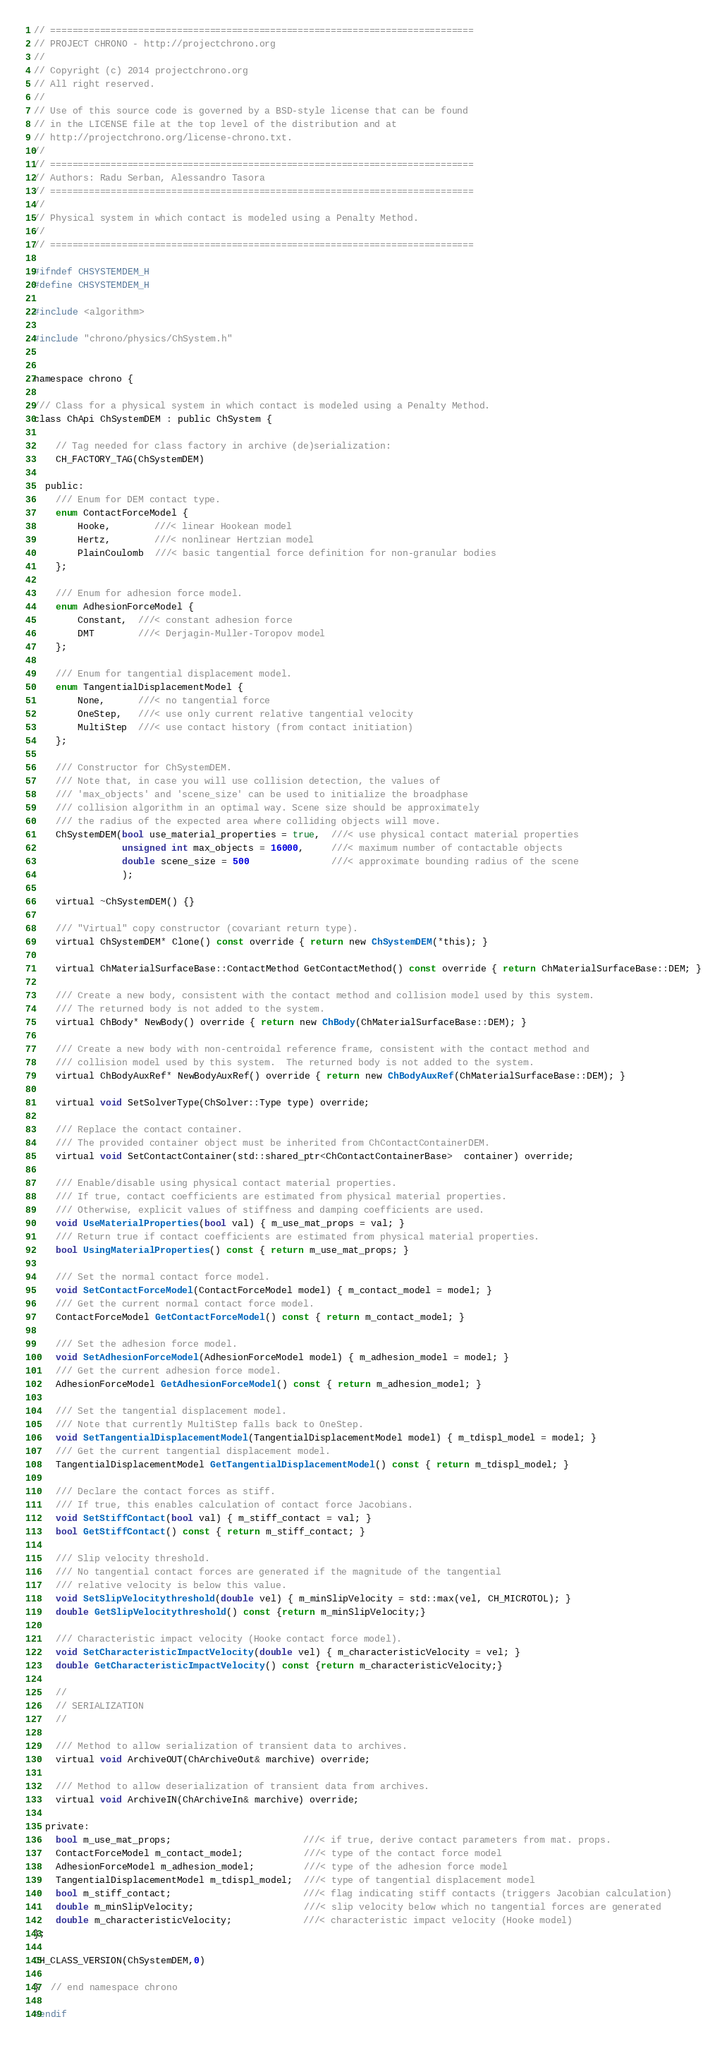Convert code to text. <code><loc_0><loc_0><loc_500><loc_500><_C_>// =============================================================================
// PROJECT CHRONO - http://projectchrono.org
//
// Copyright (c) 2014 projectchrono.org
// All right reserved.
//
// Use of this source code is governed by a BSD-style license that can be found
// in the LICENSE file at the top level of the distribution and at
// http://projectchrono.org/license-chrono.txt.
//
// =============================================================================
// Authors: Radu Serban, Alessandro Tasora
// =============================================================================
//
// Physical system in which contact is modeled using a Penalty Method.
//
// =============================================================================

#ifndef CHSYSTEMDEM_H
#define CHSYSTEMDEM_H

#include <algorithm>

#include "chrono/physics/ChSystem.h"


namespace chrono {

/// Class for a physical system in which contact is modeled using a Penalty Method.
class ChApi ChSystemDEM : public ChSystem {

    // Tag needed for class factory in archive (de)serialization:
    CH_FACTORY_TAG(ChSystemDEM)

  public:
    /// Enum for DEM contact type.
    enum ContactForceModel {
        Hooke,        ///< linear Hookean model
        Hertz,        ///< nonlinear Hertzian model
        PlainCoulomb  ///< basic tangential force definition for non-granular bodies
    };

    /// Enum for adhesion force model.
    enum AdhesionForceModel {
        Constant,  ///< constant adhesion force
        DMT        ///< Derjagin-Muller-Toropov model
    };

    /// Enum for tangential displacement model.
    enum TangentialDisplacementModel {
        None,      ///< no tangential force
        OneStep,   ///< use only current relative tangential velocity
        MultiStep  ///< use contact history (from contact initiation)
    };

    /// Constructor for ChSystemDEM.
    /// Note that, in case you will use collision detection, the values of
    /// 'max_objects' and 'scene_size' can be used to initialize the broadphase
    /// collision algorithm in an optimal way. Scene size should be approximately
    /// the radius of the expected area where colliding objects will move.
    ChSystemDEM(bool use_material_properties = true,  ///< use physical contact material properties
                unsigned int max_objects = 16000,     ///< maximum number of contactable objects
                double scene_size = 500               ///< approximate bounding radius of the scene
                );

    virtual ~ChSystemDEM() {}

    /// "Virtual" copy constructor (covariant return type).
    virtual ChSystemDEM* Clone() const override { return new ChSystemDEM(*this); }

    virtual ChMaterialSurfaceBase::ContactMethod GetContactMethod() const override { return ChMaterialSurfaceBase::DEM; }

    /// Create a new body, consistent with the contact method and collision model used by this system.
    /// The returned body is not added to the system.
    virtual ChBody* NewBody() override { return new ChBody(ChMaterialSurfaceBase::DEM); }

    /// Create a new body with non-centroidal reference frame, consistent with the contact method and
    /// collision model used by this system.  The returned body is not added to the system.
    virtual ChBodyAuxRef* NewBodyAuxRef() override { return new ChBodyAuxRef(ChMaterialSurfaceBase::DEM); }

    virtual void SetSolverType(ChSolver::Type type) override;

    /// Replace the contact container. 
    /// The provided container object must be inherited from ChContactContainerDEM.
    virtual void SetContactContainer(std::shared_ptr<ChContactContainerBase>  container) override;

    /// Enable/disable using physical contact material properties.
    /// If true, contact coefficients are estimated from physical material properties.
    /// Otherwise, explicit values of stiffness and damping coefficients are used.
    void UseMaterialProperties(bool val) { m_use_mat_props = val; }
    /// Return true if contact coefficients are estimated from physical material properties.
    bool UsingMaterialProperties() const { return m_use_mat_props; }

    /// Set the normal contact force model.
    void SetContactForceModel(ContactForceModel model) { m_contact_model = model; }
    /// Get the current normal contact force model.
    ContactForceModel GetContactForceModel() const { return m_contact_model; }

    /// Set the adhesion force model.
    void SetAdhesionForceModel(AdhesionForceModel model) { m_adhesion_model = model; }
    /// Get the current adhesion force model.
    AdhesionForceModel GetAdhesionForceModel() const { return m_adhesion_model; }

    /// Set the tangential displacement model.
    /// Note that currently MultiStep falls back to OneStep.
    void SetTangentialDisplacementModel(TangentialDisplacementModel model) { m_tdispl_model = model; }
    /// Get the current tangential displacement model.
    TangentialDisplacementModel GetTangentialDisplacementModel() const { return m_tdispl_model; }

    /// Declare the contact forces as stiff.
    /// If true, this enables calculation of contact force Jacobians.
    void SetStiffContact(bool val) { m_stiff_contact = val; }
    bool GetStiffContact() const { return m_stiff_contact; }

    /// Slip velocity threshold. 
    /// No tangential contact forces are generated if the magnitude of the tangential
    /// relative velocity is below this value.
    void SetSlipVelocitythreshold(double vel) { m_minSlipVelocity = std::max(vel, CH_MICROTOL); }
    double GetSlipVelocitythreshold() const {return m_minSlipVelocity;}

    /// Characteristic impact velocity (Hooke contact force model).
    void SetCharacteristicImpactVelocity(double vel) { m_characteristicVelocity = vel; }
    double GetCharacteristicImpactVelocity() const {return m_characteristicVelocity;}

    //
    // SERIALIZATION
    //

    /// Method to allow serialization of transient data to archives.
    virtual void ArchiveOUT(ChArchiveOut& marchive) override;

    /// Method to allow deserialization of transient data from archives.
    virtual void ArchiveIN(ChArchiveIn& marchive) override;

  private:
    bool m_use_mat_props;                        ///< if true, derive contact parameters from mat. props.
    ContactForceModel m_contact_model;           ///< type of the contact force model
    AdhesionForceModel m_adhesion_model;         ///< type of the adhesion force model
    TangentialDisplacementModel m_tdispl_model;  ///< type of tangential displacement model
    bool m_stiff_contact;                        ///< flag indicating stiff contacts (triggers Jacobian calculation)
    double m_minSlipVelocity;                    ///< slip velocity below which no tangential forces are generated
    double m_characteristicVelocity;             ///< characteristic impact velocity (Hooke model)
};

CH_CLASS_VERSION(ChSystemDEM,0)

}  // end namespace chrono

#endif
</code> 